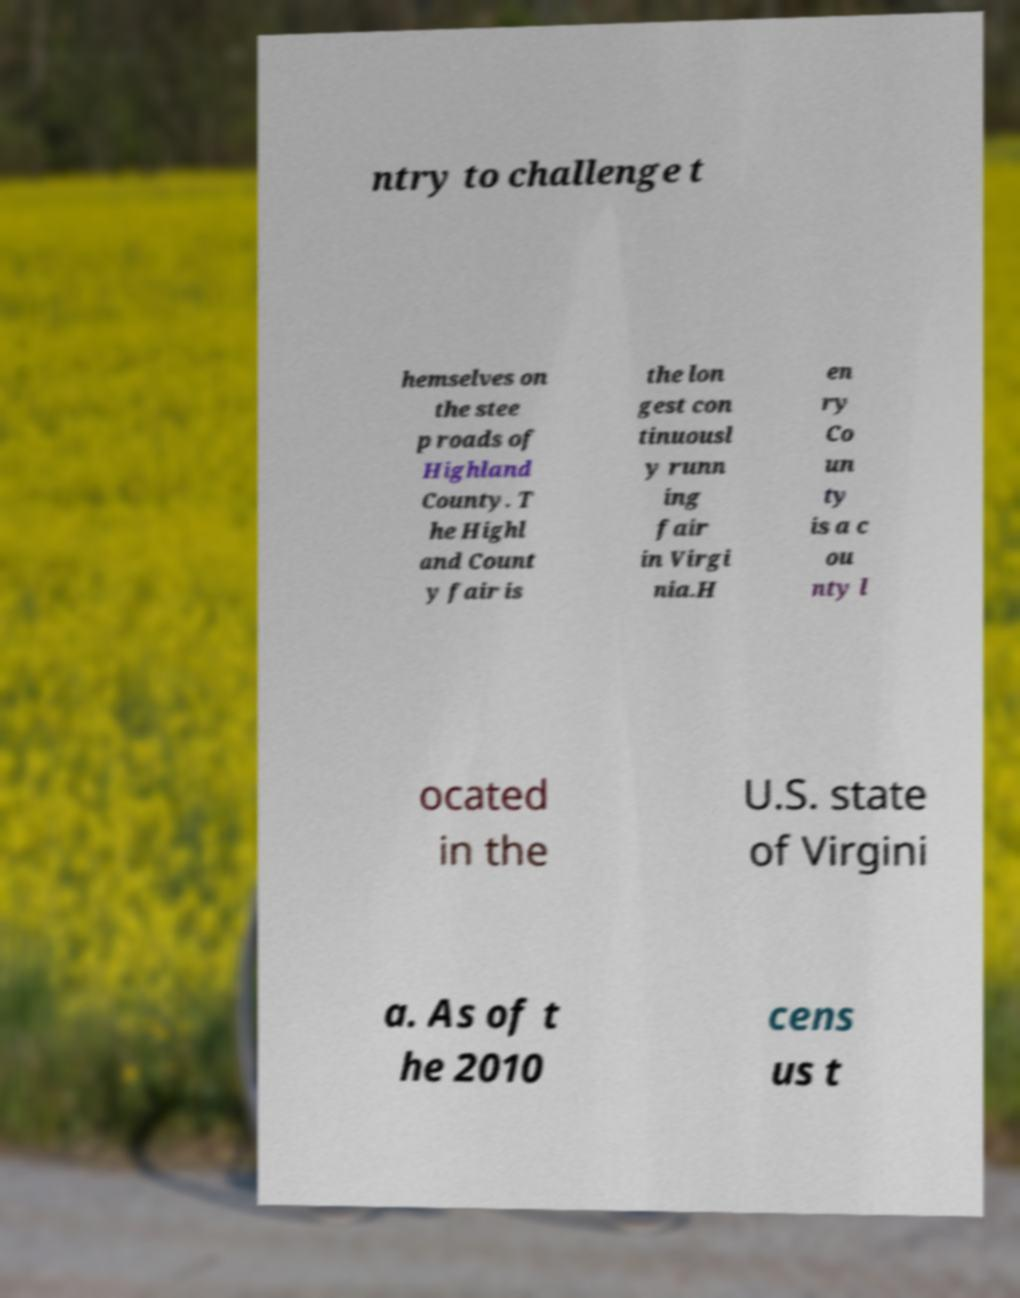Please read and relay the text visible in this image. What does it say? ntry to challenge t hemselves on the stee p roads of Highland County. T he Highl and Count y fair is the lon gest con tinuousl y runn ing fair in Virgi nia.H en ry Co un ty is a c ou nty l ocated in the U.S. state of Virgini a. As of t he 2010 cens us t 